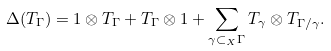Convert formula to latex. <formula><loc_0><loc_0><loc_500><loc_500>\Delta ( T _ { \Gamma } ) = 1 \otimes T _ { \Gamma } + T _ { \Gamma } \otimes 1 + \sum _ { \gamma \subset _ { X } \Gamma } T _ { \gamma } \otimes T _ { \Gamma / \gamma } .</formula> 